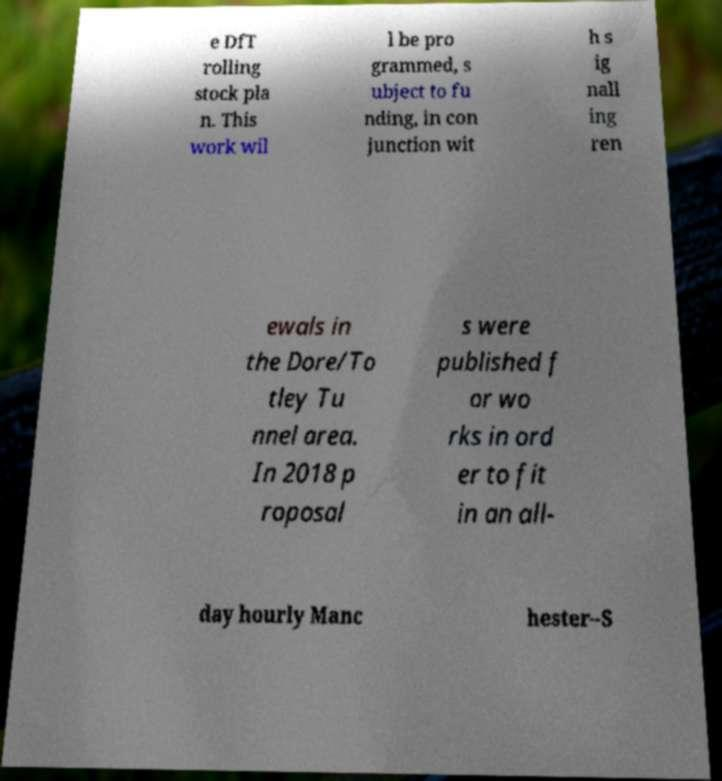Please identify and transcribe the text found in this image. e DfT rolling stock pla n. This work wil l be pro grammed, s ubject to fu nding, in con junction wit h s ig nall ing ren ewals in the Dore/To tley Tu nnel area. In 2018 p roposal s were published f or wo rks in ord er to fit in an all- day hourly Manc hester–S 